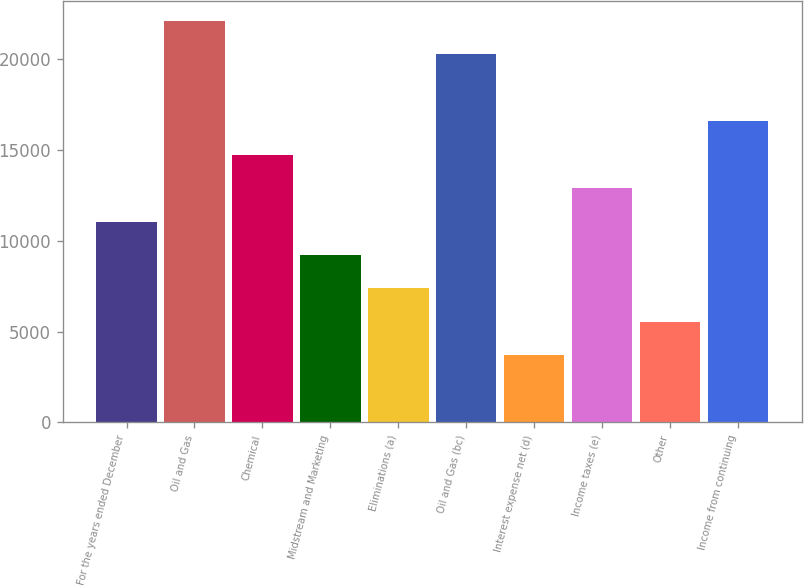<chart> <loc_0><loc_0><loc_500><loc_500><bar_chart><fcel>For the years ended December<fcel>Oil and Gas<fcel>Chemical<fcel>Midstream and Marketing<fcel>Eliminations (a)<fcel>Oil and Gas (bc)<fcel>Interest expense net (d)<fcel>Income taxes (e)<fcel>Other<fcel>Income from continuing<nl><fcel>11054.7<fcel>22101.2<fcel>14736.9<fcel>9213.67<fcel>7372.6<fcel>20260.1<fcel>3690.46<fcel>12895.8<fcel>5531.53<fcel>16578<nl></chart> 